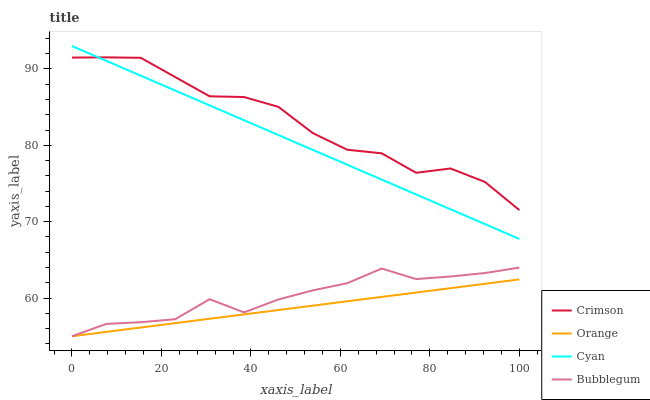Does Orange have the minimum area under the curve?
Answer yes or no. Yes. Does Crimson have the maximum area under the curve?
Answer yes or no. Yes. Does Bubblegum have the minimum area under the curve?
Answer yes or no. No. Does Bubblegum have the maximum area under the curve?
Answer yes or no. No. Is Cyan the smoothest?
Answer yes or no. Yes. Is Crimson the roughest?
Answer yes or no. Yes. Is Orange the smoothest?
Answer yes or no. No. Is Orange the roughest?
Answer yes or no. No. Does Orange have the lowest value?
Answer yes or no. Yes. Does Cyan have the lowest value?
Answer yes or no. No. Does Cyan have the highest value?
Answer yes or no. Yes. Does Bubblegum have the highest value?
Answer yes or no. No. Is Bubblegum less than Crimson?
Answer yes or no. Yes. Is Crimson greater than Bubblegum?
Answer yes or no. Yes. Does Cyan intersect Crimson?
Answer yes or no. Yes. Is Cyan less than Crimson?
Answer yes or no. No. Is Cyan greater than Crimson?
Answer yes or no. No. Does Bubblegum intersect Crimson?
Answer yes or no. No. 